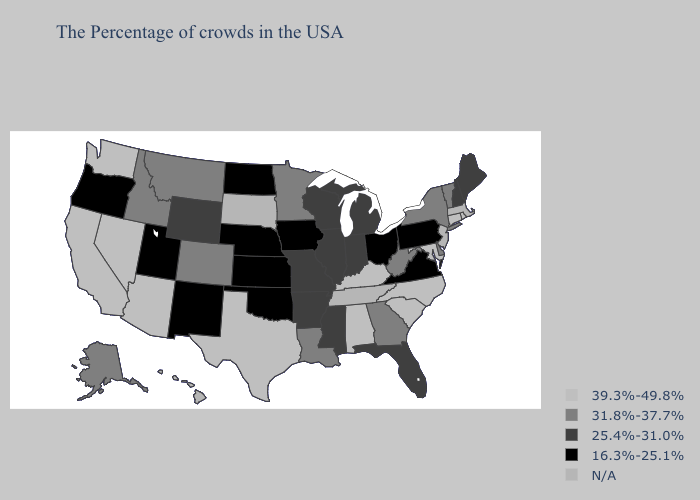Name the states that have a value in the range 31.8%-37.7%?
Give a very brief answer. Vermont, New York, Delaware, West Virginia, Georgia, Louisiana, Minnesota, Colorado, Montana, Idaho, Alaska. Does Arkansas have the lowest value in the USA?
Keep it brief. No. Name the states that have a value in the range 25.4%-31.0%?
Answer briefly. Maine, New Hampshire, Florida, Michigan, Indiana, Wisconsin, Illinois, Mississippi, Missouri, Arkansas, Wyoming. What is the value of New Hampshire?
Write a very short answer. 25.4%-31.0%. What is the highest value in the Northeast ?
Give a very brief answer. 39.3%-49.8%. Does Arizona have the highest value in the USA?
Give a very brief answer. Yes. Name the states that have a value in the range 16.3%-25.1%?
Concise answer only. Pennsylvania, Virginia, Ohio, Iowa, Kansas, Nebraska, Oklahoma, North Dakota, New Mexico, Utah, Oregon. Does the first symbol in the legend represent the smallest category?
Be succinct. No. Does Maryland have the highest value in the USA?
Write a very short answer. Yes. Does Minnesota have the highest value in the MidWest?
Write a very short answer. Yes. Among the states that border Louisiana , does Texas have the highest value?
Quick response, please. Yes. Does New Hampshire have the highest value in the Northeast?
Quick response, please. No. What is the lowest value in the West?
Be succinct. 16.3%-25.1%. What is the value of Arkansas?
Answer briefly. 25.4%-31.0%. 